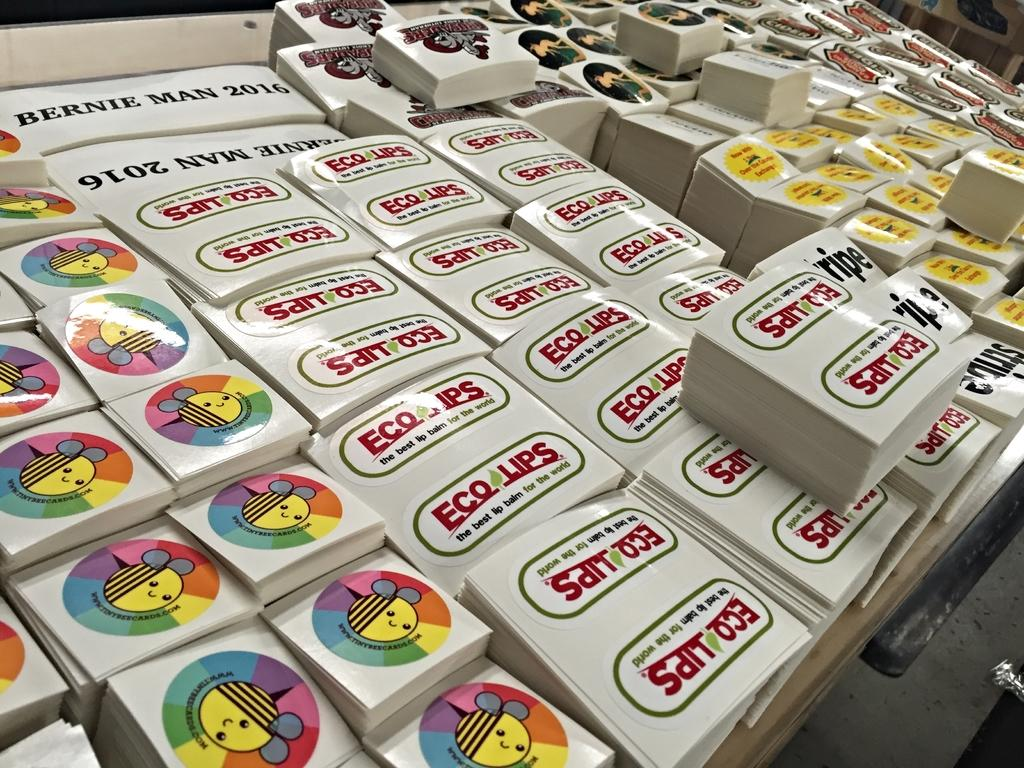What objects are on the table in the image? There are papers on the table in the image. What might the papers be used for? The papers might be used for writing, reading, or other purposes. Can you describe the table in the image? The table is a surface where the papers are placed, but no specific details about the table are provided. What type of chain can be seen hanging from the bed in the image? There is no bed or chain present in the image; it only features papers on a table. 